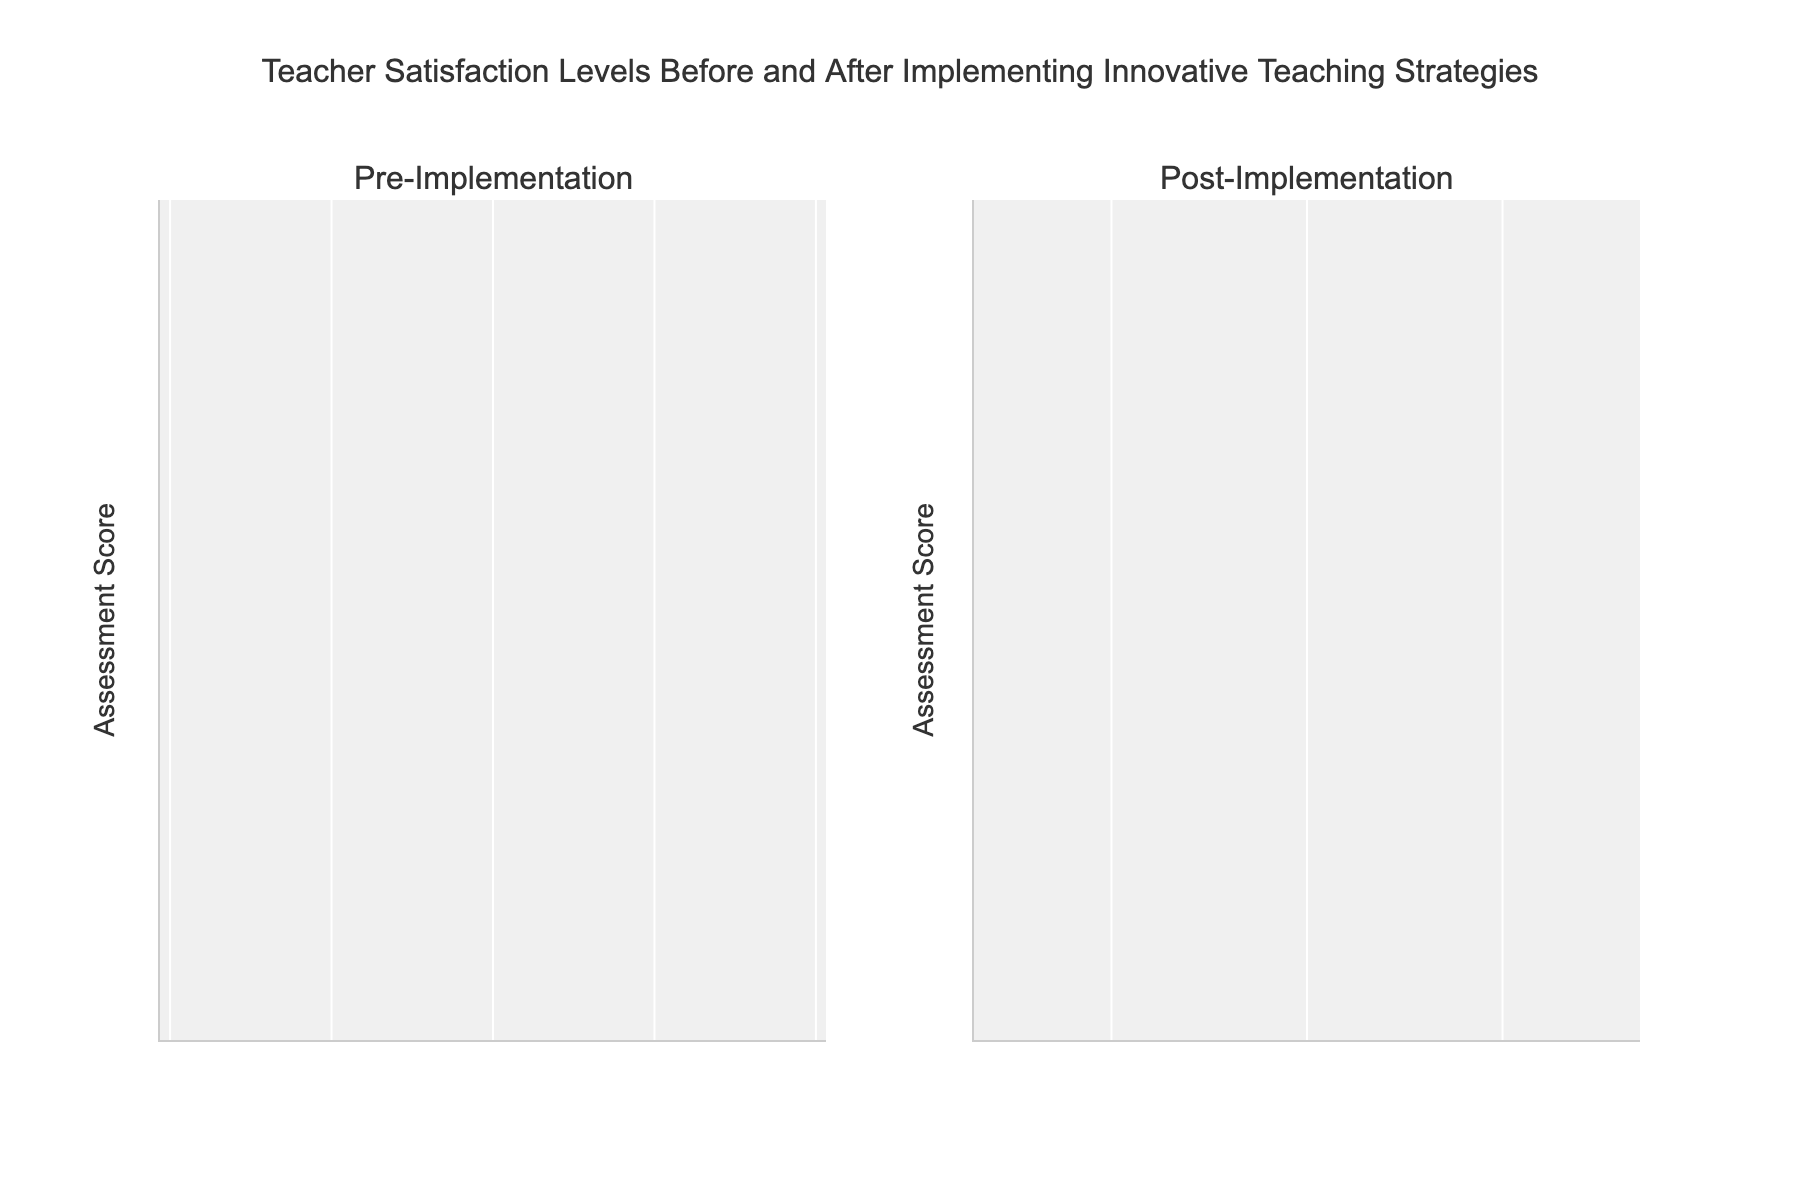What is the title of the figure? The title of the figure is written at the top and typically summarizes the content of the chart.
Answer: Teacher Satisfaction Levels Before and After Implementing Innovative Teaching Strategies What are the two groups compared in the figure? The subplot titles indicate the groups being compared, labeled as "Pre-Implementation" and "Post-Implementation."
Answer: Pre-Implementation and Post-Implementation What is the range of assessment scores shown on the y-axis? Observing the y-axis grid lines and ticks, the range is labeled from 3 to 5.
Answer: 3 to 5 How does the maximum assessment score differ between the pre-implementation and post-implementation periods? The highest point of density on the violins indicates the maximum score. In the pre-implementation, it reaches up to around 4.5, whereas in the post-implementation, it reaches 4.9.
Answer: Increases from 4.5 to 4.9 What is the average assessment score pre-implementation compared to post-implementation? By averaging the data points: Pre: (4.0 + 3.5 + 4.2 + 3.6 + 4.1 + 3.8 + 4.5 + 3.9 + 4.3 + 3.7)/10 = 4.06; Post: (4.5 + 4.2 + 4.8 + 4.1 + 4.7 + 4.3 + 4.9 + 4.5 + 4.6 + 4.2)/10 = 4.48. The average increased from 4.06 to 4.48.
Answer: Increased from 4.06 to 4.48 What is the interquartile range (IQR) of the assessment scores for pre-implementation? The IQR is the difference between the first and third quartiles. Pre-implementation data set sorted: 3.5, 3.6, 3.7, 3.8, 3.9, 4.0, 4.1, 4.2, 4.3, 4.5. Q1 (25th percentile) is (3.7+3.8)/2 = 3.75 and Q3 (75th percentile) is (4.1+4.2)/2 = 4.15. IQR is 4.15 - 3.75 = 0.4.
Answer: 0.4 Which group has a higher median assessment score, pre-implementation or post-implementation? The median is the middle value once the data is sorted. Pre: 3.5, 3.6, 3.7, 3.8, 3.9, [4.0], 4.1, 4.2, 4.3, 4.5 (Median = 4.0). Post: 4.1, 4.2, 4.2, 4.3, 4.5, [4.5], 4.6, 4.7, 4.8, 4.9 (Median = 4.5).
Answer: Post-Implementation How much higher is the maximum assessment score post-implementation compared to the pre-implementation median score? The maximum post-implementation score is 4.9 and the pre-implementation median score is 4.0. The difference is 4.9 - 4.0 = 0.9.
Answer: 0.9 How do the distribution shapes compare between the pre-implementation and post-implementation periods? The pre-implementation distribution is relatively thinner and more spread, indicating variability and moderate satisfaction. The post-implementation is more concentrated at higher scores, showing increased and more consistent satisfaction.
Answer: More concentrated and higher satisfaction post-implementation Is there overlap between the lowest score post-implementation and the highest score pre-implementation? The lowest post-implementation score is 4.1, and the highest pre-implementation score is 4.5. There is no overlap as 4.1 is higher than the pre-implementation median but falls within the pre-implementation range.
Answer: No overlap 